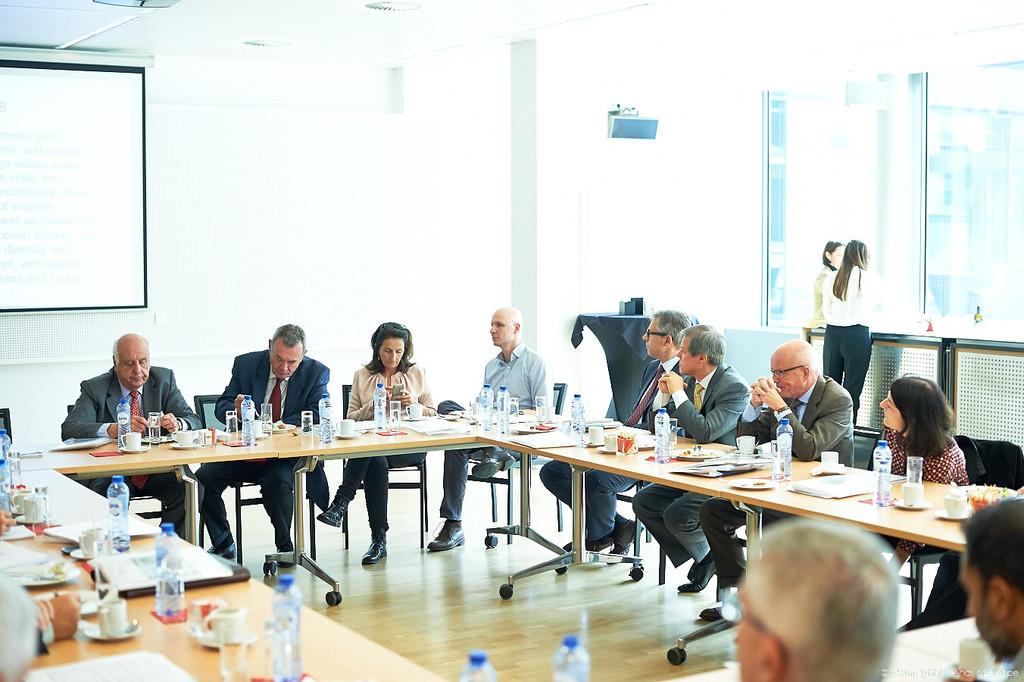How many people are in the image? There is a group of people in the image. What is on the table in the image? There is a bottle, a cup, and a saucer on the table. What can be seen in the background of the image? There is a projector and a window in the background. Where is the faucet located in the image? There is no faucet present in the image. What type of discussion is taking place among the people in the image? The image does not provide any information about the content of the discussion among the people. 